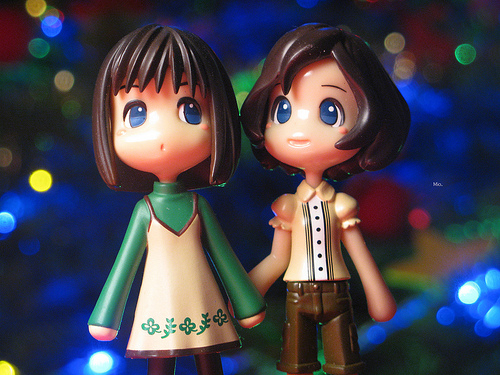<image>
Is the toy to the left of the toy? Yes. From this viewpoint, the toy is positioned to the left side relative to the toy. 